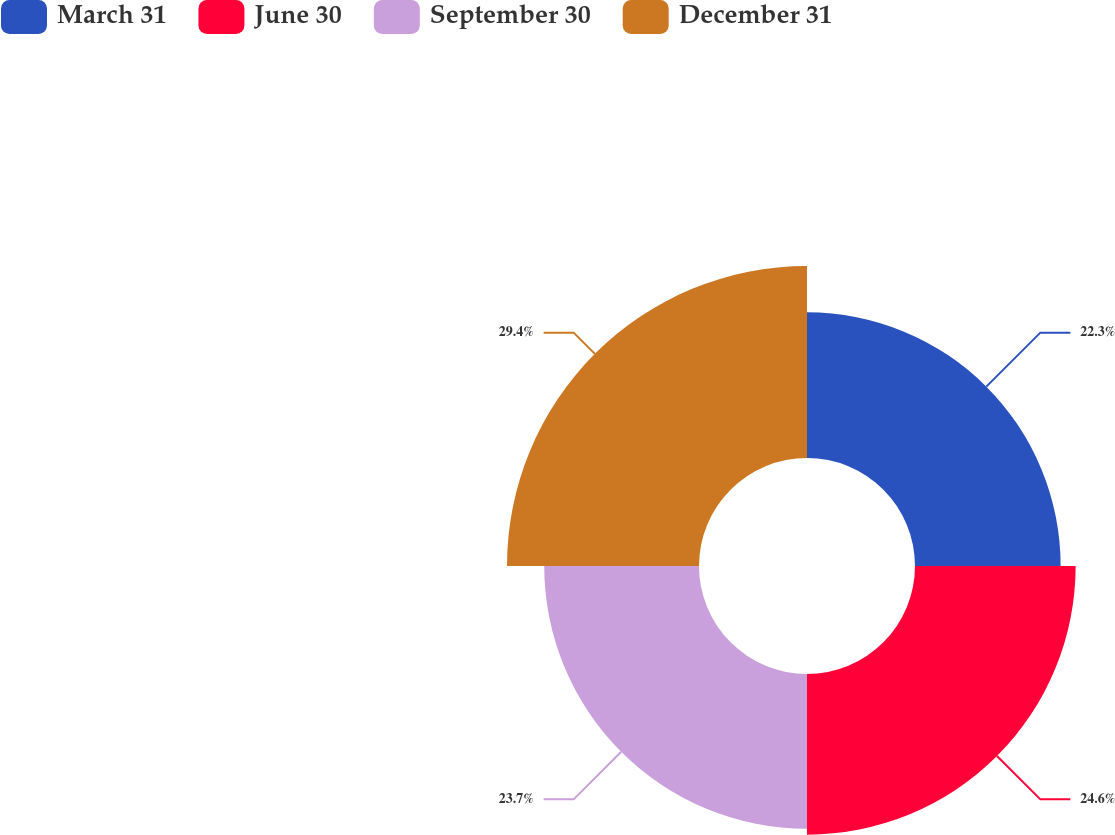Convert chart. <chart><loc_0><loc_0><loc_500><loc_500><pie_chart><fcel>March 31<fcel>June 30<fcel>September 30<fcel>December 31<nl><fcel>22.3%<fcel>24.6%<fcel>23.7%<fcel>29.4%<nl></chart> 